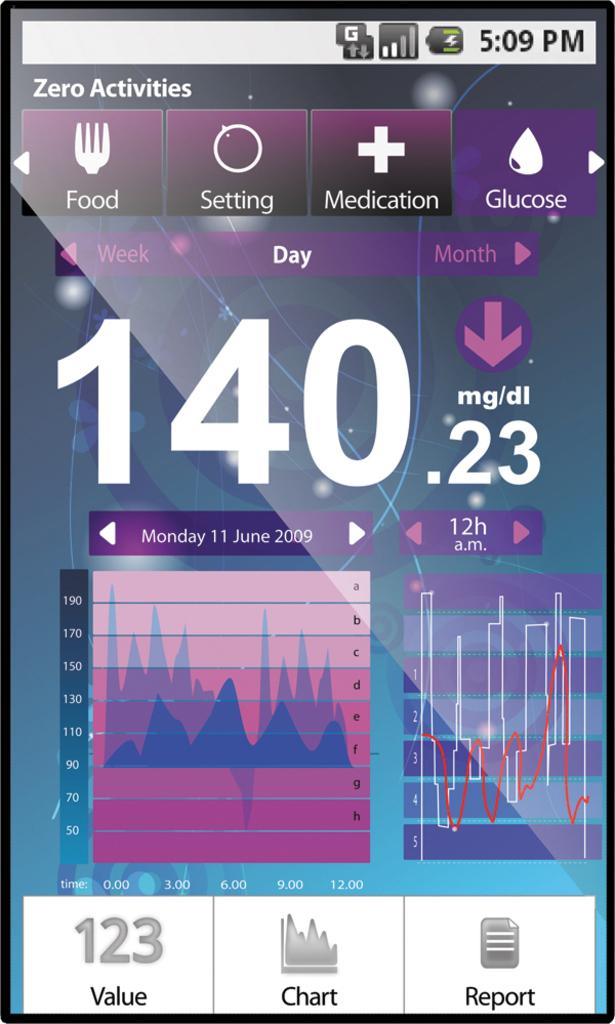<image>
Present a compact description of the photo's key features. A blood glucose reading from Monday June 11th 2009 is shown as a screen shot. 